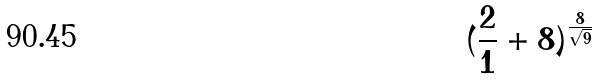<formula> <loc_0><loc_0><loc_500><loc_500>( \frac { 2 } { 1 } + 8 ) ^ { \frac { 8 } { \sqrt { 9 } } }</formula> 